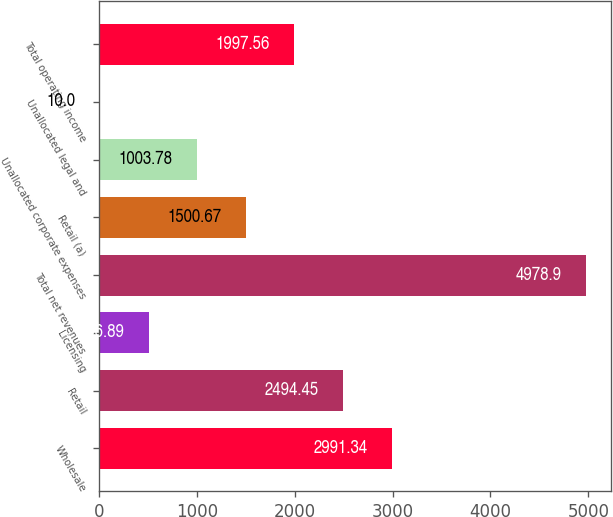<chart> <loc_0><loc_0><loc_500><loc_500><bar_chart><fcel>Wholesale<fcel>Retail<fcel>Licensing<fcel>Total net revenues<fcel>Retail (a)<fcel>Unallocated corporate expenses<fcel>Unallocated legal and<fcel>Total operating income<nl><fcel>2991.34<fcel>2494.45<fcel>506.89<fcel>4978.9<fcel>1500.67<fcel>1003.78<fcel>10<fcel>1997.56<nl></chart> 